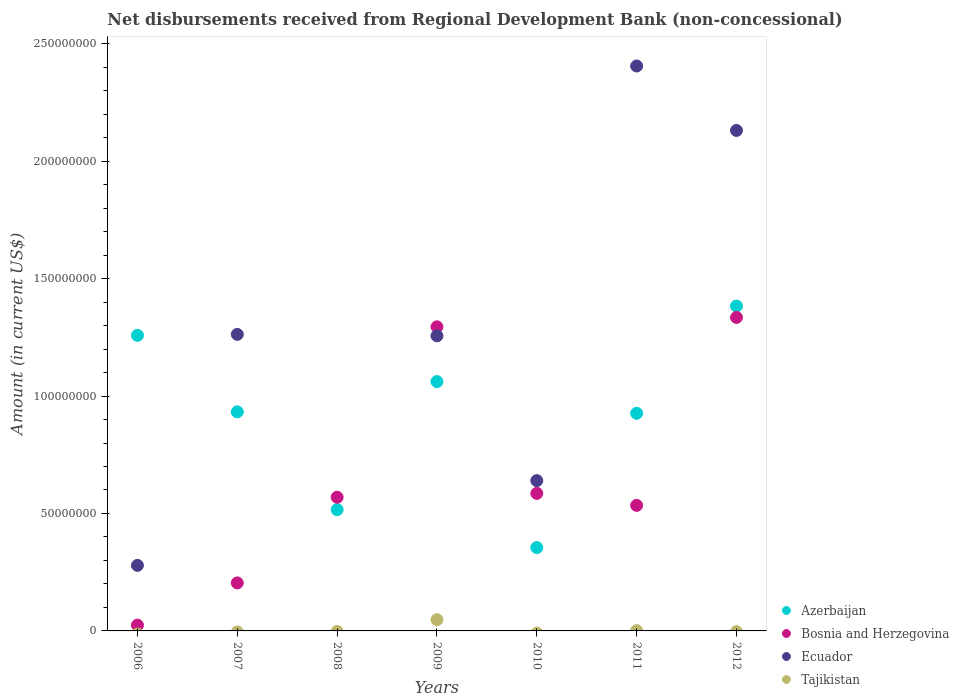How many different coloured dotlines are there?
Give a very brief answer. 4. What is the amount of disbursements received from Regional Development Bank in Ecuador in 2010?
Make the answer very short. 6.40e+07. Across all years, what is the maximum amount of disbursements received from Regional Development Bank in Ecuador?
Ensure brevity in your answer.  2.41e+08. Across all years, what is the minimum amount of disbursements received from Regional Development Bank in Bosnia and Herzegovina?
Your answer should be very brief. 2.46e+06. In which year was the amount of disbursements received from Regional Development Bank in Bosnia and Herzegovina maximum?
Provide a short and direct response. 2012. What is the total amount of disbursements received from Regional Development Bank in Tajikistan in the graph?
Keep it short and to the point. 4.91e+06. What is the difference between the amount of disbursements received from Regional Development Bank in Azerbaijan in 2007 and that in 2012?
Give a very brief answer. -4.50e+07. What is the difference between the amount of disbursements received from Regional Development Bank in Azerbaijan in 2006 and the amount of disbursements received from Regional Development Bank in Ecuador in 2009?
Give a very brief answer. 2.19e+05. What is the average amount of disbursements received from Regional Development Bank in Ecuador per year?
Offer a terse response. 1.14e+08. In the year 2009, what is the difference between the amount of disbursements received from Regional Development Bank in Tajikistan and amount of disbursements received from Regional Development Bank in Ecuador?
Provide a short and direct response. -1.21e+08. What is the ratio of the amount of disbursements received from Regional Development Bank in Ecuador in 2007 to that in 2011?
Provide a short and direct response. 0.52. Is the amount of disbursements received from Regional Development Bank in Azerbaijan in 2006 less than that in 2009?
Your response must be concise. No. What is the difference between the highest and the second highest amount of disbursements received from Regional Development Bank in Ecuador?
Ensure brevity in your answer.  2.74e+07. What is the difference between the highest and the lowest amount of disbursements received from Regional Development Bank in Ecuador?
Your answer should be compact. 2.41e+08. Is the sum of the amount of disbursements received from Regional Development Bank in Azerbaijan in 2006 and 2010 greater than the maximum amount of disbursements received from Regional Development Bank in Ecuador across all years?
Provide a short and direct response. No. Is it the case that in every year, the sum of the amount of disbursements received from Regional Development Bank in Tajikistan and amount of disbursements received from Regional Development Bank in Bosnia and Herzegovina  is greater than the sum of amount of disbursements received from Regional Development Bank in Azerbaijan and amount of disbursements received from Regional Development Bank in Ecuador?
Your answer should be compact. No. Is it the case that in every year, the sum of the amount of disbursements received from Regional Development Bank in Azerbaijan and amount of disbursements received from Regional Development Bank in Tajikistan  is greater than the amount of disbursements received from Regional Development Bank in Bosnia and Herzegovina?
Make the answer very short. No. Is the amount of disbursements received from Regional Development Bank in Tajikistan strictly greater than the amount of disbursements received from Regional Development Bank in Ecuador over the years?
Ensure brevity in your answer.  No. Is the amount of disbursements received from Regional Development Bank in Tajikistan strictly less than the amount of disbursements received from Regional Development Bank in Bosnia and Herzegovina over the years?
Keep it short and to the point. Yes. Does the graph contain grids?
Offer a very short reply. No. Where does the legend appear in the graph?
Provide a short and direct response. Bottom right. How many legend labels are there?
Offer a terse response. 4. What is the title of the graph?
Offer a very short reply. Net disbursements received from Regional Development Bank (non-concessional). Does "Iraq" appear as one of the legend labels in the graph?
Ensure brevity in your answer.  No. What is the label or title of the X-axis?
Give a very brief answer. Years. What is the Amount (in current US$) in Azerbaijan in 2006?
Offer a terse response. 1.26e+08. What is the Amount (in current US$) of Bosnia and Herzegovina in 2006?
Your answer should be very brief. 2.46e+06. What is the Amount (in current US$) of Ecuador in 2006?
Offer a very short reply. 2.79e+07. What is the Amount (in current US$) in Azerbaijan in 2007?
Ensure brevity in your answer.  9.33e+07. What is the Amount (in current US$) in Bosnia and Herzegovina in 2007?
Ensure brevity in your answer.  2.04e+07. What is the Amount (in current US$) of Ecuador in 2007?
Ensure brevity in your answer.  1.26e+08. What is the Amount (in current US$) of Azerbaijan in 2008?
Keep it short and to the point. 5.16e+07. What is the Amount (in current US$) in Bosnia and Herzegovina in 2008?
Your answer should be very brief. 5.69e+07. What is the Amount (in current US$) in Tajikistan in 2008?
Your answer should be very brief. 0. What is the Amount (in current US$) in Azerbaijan in 2009?
Offer a terse response. 1.06e+08. What is the Amount (in current US$) of Bosnia and Herzegovina in 2009?
Your response must be concise. 1.29e+08. What is the Amount (in current US$) of Ecuador in 2009?
Ensure brevity in your answer.  1.26e+08. What is the Amount (in current US$) of Tajikistan in 2009?
Your answer should be very brief. 4.79e+06. What is the Amount (in current US$) of Azerbaijan in 2010?
Make the answer very short. 3.55e+07. What is the Amount (in current US$) in Bosnia and Herzegovina in 2010?
Offer a very short reply. 5.86e+07. What is the Amount (in current US$) in Ecuador in 2010?
Offer a very short reply. 6.40e+07. What is the Amount (in current US$) of Tajikistan in 2010?
Your answer should be compact. 0. What is the Amount (in current US$) in Azerbaijan in 2011?
Make the answer very short. 9.27e+07. What is the Amount (in current US$) in Bosnia and Herzegovina in 2011?
Give a very brief answer. 5.34e+07. What is the Amount (in current US$) in Ecuador in 2011?
Your answer should be compact. 2.41e+08. What is the Amount (in current US$) of Tajikistan in 2011?
Make the answer very short. 1.25e+05. What is the Amount (in current US$) in Azerbaijan in 2012?
Offer a terse response. 1.38e+08. What is the Amount (in current US$) of Bosnia and Herzegovina in 2012?
Ensure brevity in your answer.  1.33e+08. What is the Amount (in current US$) of Ecuador in 2012?
Provide a succinct answer. 2.13e+08. What is the Amount (in current US$) of Tajikistan in 2012?
Provide a short and direct response. 0. Across all years, what is the maximum Amount (in current US$) of Azerbaijan?
Keep it short and to the point. 1.38e+08. Across all years, what is the maximum Amount (in current US$) of Bosnia and Herzegovina?
Keep it short and to the point. 1.33e+08. Across all years, what is the maximum Amount (in current US$) of Ecuador?
Offer a very short reply. 2.41e+08. Across all years, what is the maximum Amount (in current US$) in Tajikistan?
Ensure brevity in your answer.  4.79e+06. Across all years, what is the minimum Amount (in current US$) in Azerbaijan?
Give a very brief answer. 3.55e+07. Across all years, what is the minimum Amount (in current US$) in Bosnia and Herzegovina?
Offer a terse response. 2.46e+06. What is the total Amount (in current US$) in Azerbaijan in the graph?
Keep it short and to the point. 6.43e+08. What is the total Amount (in current US$) in Bosnia and Herzegovina in the graph?
Your response must be concise. 4.55e+08. What is the total Amount (in current US$) of Ecuador in the graph?
Keep it short and to the point. 7.97e+08. What is the total Amount (in current US$) of Tajikistan in the graph?
Give a very brief answer. 4.91e+06. What is the difference between the Amount (in current US$) of Azerbaijan in 2006 and that in 2007?
Your answer should be compact. 3.26e+07. What is the difference between the Amount (in current US$) in Bosnia and Herzegovina in 2006 and that in 2007?
Provide a short and direct response. -1.80e+07. What is the difference between the Amount (in current US$) in Ecuador in 2006 and that in 2007?
Offer a terse response. -9.83e+07. What is the difference between the Amount (in current US$) of Azerbaijan in 2006 and that in 2008?
Offer a very short reply. 7.42e+07. What is the difference between the Amount (in current US$) of Bosnia and Herzegovina in 2006 and that in 2008?
Your answer should be compact. -5.45e+07. What is the difference between the Amount (in current US$) in Azerbaijan in 2006 and that in 2009?
Provide a succinct answer. 1.97e+07. What is the difference between the Amount (in current US$) in Bosnia and Herzegovina in 2006 and that in 2009?
Offer a very short reply. -1.27e+08. What is the difference between the Amount (in current US$) in Ecuador in 2006 and that in 2009?
Your answer should be very brief. -9.77e+07. What is the difference between the Amount (in current US$) in Azerbaijan in 2006 and that in 2010?
Your answer should be compact. 9.04e+07. What is the difference between the Amount (in current US$) of Bosnia and Herzegovina in 2006 and that in 2010?
Provide a short and direct response. -5.61e+07. What is the difference between the Amount (in current US$) in Ecuador in 2006 and that in 2010?
Your answer should be very brief. -3.61e+07. What is the difference between the Amount (in current US$) of Azerbaijan in 2006 and that in 2011?
Provide a short and direct response. 3.32e+07. What is the difference between the Amount (in current US$) of Bosnia and Herzegovina in 2006 and that in 2011?
Offer a very short reply. -5.10e+07. What is the difference between the Amount (in current US$) in Ecuador in 2006 and that in 2011?
Make the answer very short. -2.13e+08. What is the difference between the Amount (in current US$) of Azerbaijan in 2006 and that in 2012?
Your answer should be very brief. -1.25e+07. What is the difference between the Amount (in current US$) in Bosnia and Herzegovina in 2006 and that in 2012?
Your answer should be compact. -1.31e+08. What is the difference between the Amount (in current US$) of Ecuador in 2006 and that in 2012?
Give a very brief answer. -1.85e+08. What is the difference between the Amount (in current US$) of Azerbaijan in 2007 and that in 2008?
Your answer should be very brief. 4.16e+07. What is the difference between the Amount (in current US$) of Bosnia and Herzegovina in 2007 and that in 2008?
Your response must be concise. -3.65e+07. What is the difference between the Amount (in current US$) of Azerbaijan in 2007 and that in 2009?
Your answer should be very brief. -1.29e+07. What is the difference between the Amount (in current US$) of Bosnia and Herzegovina in 2007 and that in 2009?
Provide a short and direct response. -1.09e+08. What is the difference between the Amount (in current US$) of Ecuador in 2007 and that in 2009?
Provide a short and direct response. 6.24e+05. What is the difference between the Amount (in current US$) in Azerbaijan in 2007 and that in 2010?
Offer a terse response. 5.78e+07. What is the difference between the Amount (in current US$) in Bosnia and Herzegovina in 2007 and that in 2010?
Offer a very short reply. -3.81e+07. What is the difference between the Amount (in current US$) of Ecuador in 2007 and that in 2010?
Offer a terse response. 6.23e+07. What is the difference between the Amount (in current US$) of Azerbaijan in 2007 and that in 2011?
Provide a short and direct response. 6.07e+05. What is the difference between the Amount (in current US$) in Bosnia and Herzegovina in 2007 and that in 2011?
Provide a short and direct response. -3.30e+07. What is the difference between the Amount (in current US$) in Ecuador in 2007 and that in 2011?
Your answer should be compact. -1.14e+08. What is the difference between the Amount (in current US$) of Azerbaijan in 2007 and that in 2012?
Provide a succinct answer. -4.50e+07. What is the difference between the Amount (in current US$) in Bosnia and Herzegovina in 2007 and that in 2012?
Give a very brief answer. -1.13e+08. What is the difference between the Amount (in current US$) of Ecuador in 2007 and that in 2012?
Keep it short and to the point. -8.68e+07. What is the difference between the Amount (in current US$) in Azerbaijan in 2008 and that in 2009?
Offer a terse response. -5.45e+07. What is the difference between the Amount (in current US$) of Bosnia and Herzegovina in 2008 and that in 2009?
Offer a very short reply. -7.26e+07. What is the difference between the Amount (in current US$) of Azerbaijan in 2008 and that in 2010?
Make the answer very short. 1.62e+07. What is the difference between the Amount (in current US$) in Bosnia and Herzegovina in 2008 and that in 2010?
Your answer should be very brief. -1.64e+06. What is the difference between the Amount (in current US$) in Azerbaijan in 2008 and that in 2011?
Ensure brevity in your answer.  -4.10e+07. What is the difference between the Amount (in current US$) in Bosnia and Herzegovina in 2008 and that in 2011?
Offer a very short reply. 3.47e+06. What is the difference between the Amount (in current US$) in Azerbaijan in 2008 and that in 2012?
Your response must be concise. -8.67e+07. What is the difference between the Amount (in current US$) in Bosnia and Herzegovina in 2008 and that in 2012?
Make the answer very short. -7.66e+07. What is the difference between the Amount (in current US$) of Azerbaijan in 2009 and that in 2010?
Make the answer very short. 7.07e+07. What is the difference between the Amount (in current US$) in Bosnia and Herzegovina in 2009 and that in 2010?
Keep it short and to the point. 7.09e+07. What is the difference between the Amount (in current US$) of Ecuador in 2009 and that in 2010?
Ensure brevity in your answer.  6.16e+07. What is the difference between the Amount (in current US$) in Azerbaijan in 2009 and that in 2011?
Provide a short and direct response. 1.35e+07. What is the difference between the Amount (in current US$) of Bosnia and Herzegovina in 2009 and that in 2011?
Provide a succinct answer. 7.60e+07. What is the difference between the Amount (in current US$) of Ecuador in 2009 and that in 2011?
Make the answer very short. -1.15e+08. What is the difference between the Amount (in current US$) of Tajikistan in 2009 and that in 2011?
Provide a succinct answer. 4.66e+06. What is the difference between the Amount (in current US$) in Azerbaijan in 2009 and that in 2012?
Give a very brief answer. -3.22e+07. What is the difference between the Amount (in current US$) in Bosnia and Herzegovina in 2009 and that in 2012?
Offer a terse response. -4.00e+06. What is the difference between the Amount (in current US$) in Ecuador in 2009 and that in 2012?
Give a very brief answer. -8.74e+07. What is the difference between the Amount (in current US$) in Azerbaijan in 2010 and that in 2011?
Your answer should be very brief. -5.72e+07. What is the difference between the Amount (in current US$) in Bosnia and Herzegovina in 2010 and that in 2011?
Offer a terse response. 5.11e+06. What is the difference between the Amount (in current US$) of Ecuador in 2010 and that in 2011?
Give a very brief answer. -1.77e+08. What is the difference between the Amount (in current US$) in Azerbaijan in 2010 and that in 2012?
Make the answer very short. -1.03e+08. What is the difference between the Amount (in current US$) of Bosnia and Herzegovina in 2010 and that in 2012?
Offer a terse response. -7.49e+07. What is the difference between the Amount (in current US$) of Ecuador in 2010 and that in 2012?
Ensure brevity in your answer.  -1.49e+08. What is the difference between the Amount (in current US$) of Azerbaijan in 2011 and that in 2012?
Your answer should be compact. -4.56e+07. What is the difference between the Amount (in current US$) in Bosnia and Herzegovina in 2011 and that in 2012?
Provide a short and direct response. -8.00e+07. What is the difference between the Amount (in current US$) in Ecuador in 2011 and that in 2012?
Offer a very short reply. 2.74e+07. What is the difference between the Amount (in current US$) in Azerbaijan in 2006 and the Amount (in current US$) in Bosnia and Herzegovina in 2007?
Offer a terse response. 1.05e+08. What is the difference between the Amount (in current US$) of Azerbaijan in 2006 and the Amount (in current US$) of Ecuador in 2007?
Give a very brief answer. -4.05e+05. What is the difference between the Amount (in current US$) in Bosnia and Herzegovina in 2006 and the Amount (in current US$) in Ecuador in 2007?
Provide a succinct answer. -1.24e+08. What is the difference between the Amount (in current US$) of Azerbaijan in 2006 and the Amount (in current US$) of Bosnia and Herzegovina in 2008?
Make the answer very short. 6.89e+07. What is the difference between the Amount (in current US$) in Azerbaijan in 2006 and the Amount (in current US$) in Bosnia and Herzegovina in 2009?
Your response must be concise. -3.62e+06. What is the difference between the Amount (in current US$) in Azerbaijan in 2006 and the Amount (in current US$) in Ecuador in 2009?
Offer a very short reply. 2.19e+05. What is the difference between the Amount (in current US$) of Azerbaijan in 2006 and the Amount (in current US$) of Tajikistan in 2009?
Make the answer very short. 1.21e+08. What is the difference between the Amount (in current US$) in Bosnia and Herzegovina in 2006 and the Amount (in current US$) in Ecuador in 2009?
Provide a succinct answer. -1.23e+08. What is the difference between the Amount (in current US$) in Bosnia and Herzegovina in 2006 and the Amount (in current US$) in Tajikistan in 2009?
Keep it short and to the point. -2.33e+06. What is the difference between the Amount (in current US$) in Ecuador in 2006 and the Amount (in current US$) in Tajikistan in 2009?
Your answer should be compact. 2.31e+07. What is the difference between the Amount (in current US$) of Azerbaijan in 2006 and the Amount (in current US$) of Bosnia and Herzegovina in 2010?
Make the answer very short. 6.73e+07. What is the difference between the Amount (in current US$) in Azerbaijan in 2006 and the Amount (in current US$) in Ecuador in 2010?
Provide a succinct answer. 6.19e+07. What is the difference between the Amount (in current US$) in Bosnia and Herzegovina in 2006 and the Amount (in current US$) in Ecuador in 2010?
Offer a terse response. -6.15e+07. What is the difference between the Amount (in current US$) of Azerbaijan in 2006 and the Amount (in current US$) of Bosnia and Herzegovina in 2011?
Your answer should be very brief. 7.24e+07. What is the difference between the Amount (in current US$) in Azerbaijan in 2006 and the Amount (in current US$) in Ecuador in 2011?
Your response must be concise. -1.15e+08. What is the difference between the Amount (in current US$) of Azerbaijan in 2006 and the Amount (in current US$) of Tajikistan in 2011?
Make the answer very short. 1.26e+08. What is the difference between the Amount (in current US$) of Bosnia and Herzegovina in 2006 and the Amount (in current US$) of Ecuador in 2011?
Provide a succinct answer. -2.38e+08. What is the difference between the Amount (in current US$) in Bosnia and Herzegovina in 2006 and the Amount (in current US$) in Tajikistan in 2011?
Provide a short and direct response. 2.33e+06. What is the difference between the Amount (in current US$) of Ecuador in 2006 and the Amount (in current US$) of Tajikistan in 2011?
Offer a very short reply. 2.78e+07. What is the difference between the Amount (in current US$) of Azerbaijan in 2006 and the Amount (in current US$) of Bosnia and Herzegovina in 2012?
Offer a very short reply. -7.61e+06. What is the difference between the Amount (in current US$) of Azerbaijan in 2006 and the Amount (in current US$) of Ecuador in 2012?
Provide a succinct answer. -8.72e+07. What is the difference between the Amount (in current US$) of Bosnia and Herzegovina in 2006 and the Amount (in current US$) of Ecuador in 2012?
Provide a succinct answer. -2.11e+08. What is the difference between the Amount (in current US$) of Azerbaijan in 2007 and the Amount (in current US$) of Bosnia and Herzegovina in 2008?
Your response must be concise. 3.64e+07. What is the difference between the Amount (in current US$) in Azerbaijan in 2007 and the Amount (in current US$) in Bosnia and Herzegovina in 2009?
Make the answer very short. -3.62e+07. What is the difference between the Amount (in current US$) of Azerbaijan in 2007 and the Amount (in current US$) of Ecuador in 2009?
Provide a short and direct response. -3.24e+07. What is the difference between the Amount (in current US$) in Azerbaijan in 2007 and the Amount (in current US$) in Tajikistan in 2009?
Provide a succinct answer. 8.85e+07. What is the difference between the Amount (in current US$) in Bosnia and Herzegovina in 2007 and the Amount (in current US$) in Ecuador in 2009?
Offer a very short reply. -1.05e+08. What is the difference between the Amount (in current US$) in Bosnia and Herzegovina in 2007 and the Amount (in current US$) in Tajikistan in 2009?
Make the answer very short. 1.57e+07. What is the difference between the Amount (in current US$) of Ecuador in 2007 and the Amount (in current US$) of Tajikistan in 2009?
Your response must be concise. 1.21e+08. What is the difference between the Amount (in current US$) in Azerbaijan in 2007 and the Amount (in current US$) in Bosnia and Herzegovina in 2010?
Make the answer very short. 3.47e+07. What is the difference between the Amount (in current US$) of Azerbaijan in 2007 and the Amount (in current US$) of Ecuador in 2010?
Offer a terse response. 2.93e+07. What is the difference between the Amount (in current US$) of Bosnia and Herzegovina in 2007 and the Amount (in current US$) of Ecuador in 2010?
Your answer should be very brief. -4.35e+07. What is the difference between the Amount (in current US$) in Azerbaijan in 2007 and the Amount (in current US$) in Bosnia and Herzegovina in 2011?
Provide a succinct answer. 3.98e+07. What is the difference between the Amount (in current US$) of Azerbaijan in 2007 and the Amount (in current US$) of Ecuador in 2011?
Ensure brevity in your answer.  -1.47e+08. What is the difference between the Amount (in current US$) of Azerbaijan in 2007 and the Amount (in current US$) of Tajikistan in 2011?
Ensure brevity in your answer.  9.31e+07. What is the difference between the Amount (in current US$) of Bosnia and Herzegovina in 2007 and the Amount (in current US$) of Ecuador in 2011?
Your response must be concise. -2.20e+08. What is the difference between the Amount (in current US$) of Bosnia and Herzegovina in 2007 and the Amount (in current US$) of Tajikistan in 2011?
Your answer should be very brief. 2.03e+07. What is the difference between the Amount (in current US$) of Ecuador in 2007 and the Amount (in current US$) of Tajikistan in 2011?
Your response must be concise. 1.26e+08. What is the difference between the Amount (in current US$) of Azerbaijan in 2007 and the Amount (in current US$) of Bosnia and Herzegovina in 2012?
Provide a succinct answer. -4.02e+07. What is the difference between the Amount (in current US$) of Azerbaijan in 2007 and the Amount (in current US$) of Ecuador in 2012?
Provide a short and direct response. -1.20e+08. What is the difference between the Amount (in current US$) in Bosnia and Herzegovina in 2007 and the Amount (in current US$) in Ecuador in 2012?
Provide a succinct answer. -1.93e+08. What is the difference between the Amount (in current US$) of Azerbaijan in 2008 and the Amount (in current US$) of Bosnia and Herzegovina in 2009?
Your response must be concise. -7.78e+07. What is the difference between the Amount (in current US$) in Azerbaijan in 2008 and the Amount (in current US$) in Ecuador in 2009?
Offer a very short reply. -7.40e+07. What is the difference between the Amount (in current US$) of Azerbaijan in 2008 and the Amount (in current US$) of Tajikistan in 2009?
Ensure brevity in your answer.  4.68e+07. What is the difference between the Amount (in current US$) of Bosnia and Herzegovina in 2008 and the Amount (in current US$) of Ecuador in 2009?
Ensure brevity in your answer.  -6.87e+07. What is the difference between the Amount (in current US$) of Bosnia and Herzegovina in 2008 and the Amount (in current US$) of Tajikistan in 2009?
Offer a terse response. 5.21e+07. What is the difference between the Amount (in current US$) of Azerbaijan in 2008 and the Amount (in current US$) of Bosnia and Herzegovina in 2010?
Make the answer very short. -6.92e+06. What is the difference between the Amount (in current US$) in Azerbaijan in 2008 and the Amount (in current US$) in Ecuador in 2010?
Give a very brief answer. -1.24e+07. What is the difference between the Amount (in current US$) of Bosnia and Herzegovina in 2008 and the Amount (in current US$) of Ecuador in 2010?
Make the answer very short. -7.08e+06. What is the difference between the Amount (in current US$) in Azerbaijan in 2008 and the Amount (in current US$) in Bosnia and Herzegovina in 2011?
Your answer should be compact. -1.81e+06. What is the difference between the Amount (in current US$) of Azerbaijan in 2008 and the Amount (in current US$) of Ecuador in 2011?
Ensure brevity in your answer.  -1.89e+08. What is the difference between the Amount (in current US$) of Azerbaijan in 2008 and the Amount (in current US$) of Tajikistan in 2011?
Give a very brief answer. 5.15e+07. What is the difference between the Amount (in current US$) of Bosnia and Herzegovina in 2008 and the Amount (in current US$) of Ecuador in 2011?
Provide a short and direct response. -1.84e+08. What is the difference between the Amount (in current US$) of Bosnia and Herzegovina in 2008 and the Amount (in current US$) of Tajikistan in 2011?
Ensure brevity in your answer.  5.68e+07. What is the difference between the Amount (in current US$) in Azerbaijan in 2008 and the Amount (in current US$) in Bosnia and Herzegovina in 2012?
Offer a terse response. -8.18e+07. What is the difference between the Amount (in current US$) of Azerbaijan in 2008 and the Amount (in current US$) of Ecuador in 2012?
Your answer should be very brief. -1.61e+08. What is the difference between the Amount (in current US$) in Bosnia and Herzegovina in 2008 and the Amount (in current US$) in Ecuador in 2012?
Your answer should be compact. -1.56e+08. What is the difference between the Amount (in current US$) in Azerbaijan in 2009 and the Amount (in current US$) in Bosnia and Herzegovina in 2010?
Ensure brevity in your answer.  4.76e+07. What is the difference between the Amount (in current US$) of Azerbaijan in 2009 and the Amount (in current US$) of Ecuador in 2010?
Offer a terse response. 4.22e+07. What is the difference between the Amount (in current US$) in Bosnia and Herzegovina in 2009 and the Amount (in current US$) in Ecuador in 2010?
Your answer should be very brief. 6.55e+07. What is the difference between the Amount (in current US$) of Azerbaijan in 2009 and the Amount (in current US$) of Bosnia and Herzegovina in 2011?
Offer a terse response. 5.27e+07. What is the difference between the Amount (in current US$) of Azerbaijan in 2009 and the Amount (in current US$) of Ecuador in 2011?
Offer a terse response. -1.34e+08. What is the difference between the Amount (in current US$) of Azerbaijan in 2009 and the Amount (in current US$) of Tajikistan in 2011?
Your response must be concise. 1.06e+08. What is the difference between the Amount (in current US$) of Bosnia and Herzegovina in 2009 and the Amount (in current US$) of Ecuador in 2011?
Keep it short and to the point. -1.11e+08. What is the difference between the Amount (in current US$) in Bosnia and Herzegovina in 2009 and the Amount (in current US$) in Tajikistan in 2011?
Ensure brevity in your answer.  1.29e+08. What is the difference between the Amount (in current US$) in Ecuador in 2009 and the Amount (in current US$) in Tajikistan in 2011?
Provide a short and direct response. 1.26e+08. What is the difference between the Amount (in current US$) in Azerbaijan in 2009 and the Amount (in current US$) in Bosnia and Herzegovina in 2012?
Your response must be concise. -2.73e+07. What is the difference between the Amount (in current US$) in Azerbaijan in 2009 and the Amount (in current US$) in Ecuador in 2012?
Offer a very short reply. -1.07e+08. What is the difference between the Amount (in current US$) in Bosnia and Herzegovina in 2009 and the Amount (in current US$) in Ecuador in 2012?
Provide a succinct answer. -8.36e+07. What is the difference between the Amount (in current US$) in Azerbaijan in 2010 and the Amount (in current US$) in Bosnia and Herzegovina in 2011?
Offer a terse response. -1.80e+07. What is the difference between the Amount (in current US$) in Azerbaijan in 2010 and the Amount (in current US$) in Ecuador in 2011?
Offer a terse response. -2.05e+08. What is the difference between the Amount (in current US$) in Azerbaijan in 2010 and the Amount (in current US$) in Tajikistan in 2011?
Provide a succinct answer. 3.54e+07. What is the difference between the Amount (in current US$) in Bosnia and Herzegovina in 2010 and the Amount (in current US$) in Ecuador in 2011?
Provide a succinct answer. -1.82e+08. What is the difference between the Amount (in current US$) in Bosnia and Herzegovina in 2010 and the Amount (in current US$) in Tajikistan in 2011?
Provide a short and direct response. 5.84e+07. What is the difference between the Amount (in current US$) of Ecuador in 2010 and the Amount (in current US$) of Tajikistan in 2011?
Make the answer very short. 6.39e+07. What is the difference between the Amount (in current US$) of Azerbaijan in 2010 and the Amount (in current US$) of Bosnia and Herzegovina in 2012?
Your response must be concise. -9.80e+07. What is the difference between the Amount (in current US$) in Azerbaijan in 2010 and the Amount (in current US$) in Ecuador in 2012?
Your answer should be very brief. -1.78e+08. What is the difference between the Amount (in current US$) in Bosnia and Herzegovina in 2010 and the Amount (in current US$) in Ecuador in 2012?
Offer a very short reply. -1.55e+08. What is the difference between the Amount (in current US$) of Azerbaijan in 2011 and the Amount (in current US$) of Bosnia and Herzegovina in 2012?
Your answer should be very brief. -4.08e+07. What is the difference between the Amount (in current US$) of Azerbaijan in 2011 and the Amount (in current US$) of Ecuador in 2012?
Offer a very short reply. -1.20e+08. What is the difference between the Amount (in current US$) of Bosnia and Herzegovina in 2011 and the Amount (in current US$) of Ecuador in 2012?
Offer a terse response. -1.60e+08. What is the average Amount (in current US$) in Azerbaijan per year?
Your answer should be compact. 9.19e+07. What is the average Amount (in current US$) of Bosnia and Herzegovina per year?
Provide a succinct answer. 6.50e+07. What is the average Amount (in current US$) of Ecuador per year?
Give a very brief answer. 1.14e+08. What is the average Amount (in current US$) of Tajikistan per year?
Offer a terse response. 7.02e+05. In the year 2006, what is the difference between the Amount (in current US$) in Azerbaijan and Amount (in current US$) in Bosnia and Herzegovina?
Ensure brevity in your answer.  1.23e+08. In the year 2006, what is the difference between the Amount (in current US$) of Azerbaijan and Amount (in current US$) of Ecuador?
Keep it short and to the point. 9.79e+07. In the year 2006, what is the difference between the Amount (in current US$) of Bosnia and Herzegovina and Amount (in current US$) of Ecuador?
Offer a terse response. -2.55e+07. In the year 2007, what is the difference between the Amount (in current US$) in Azerbaijan and Amount (in current US$) in Bosnia and Herzegovina?
Your response must be concise. 7.28e+07. In the year 2007, what is the difference between the Amount (in current US$) of Azerbaijan and Amount (in current US$) of Ecuador?
Provide a succinct answer. -3.30e+07. In the year 2007, what is the difference between the Amount (in current US$) of Bosnia and Herzegovina and Amount (in current US$) of Ecuador?
Offer a very short reply. -1.06e+08. In the year 2008, what is the difference between the Amount (in current US$) of Azerbaijan and Amount (in current US$) of Bosnia and Herzegovina?
Your answer should be very brief. -5.28e+06. In the year 2009, what is the difference between the Amount (in current US$) of Azerbaijan and Amount (in current US$) of Bosnia and Herzegovina?
Your answer should be very brief. -2.33e+07. In the year 2009, what is the difference between the Amount (in current US$) in Azerbaijan and Amount (in current US$) in Ecuador?
Offer a very short reply. -1.95e+07. In the year 2009, what is the difference between the Amount (in current US$) in Azerbaijan and Amount (in current US$) in Tajikistan?
Provide a succinct answer. 1.01e+08. In the year 2009, what is the difference between the Amount (in current US$) of Bosnia and Herzegovina and Amount (in current US$) of Ecuador?
Keep it short and to the point. 3.84e+06. In the year 2009, what is the difference between the Amount (in current US$) of Bosnia and Herzegovina and Amount (in current US$) of Tajikistan?
Your answer should be very brief. 1.25e+08. In the year 2009, what is the difference between the Amount (in current US$) in Ecuador and Amount (in current US$) in Tajikistan?
Your answer should be compact. 1.21e+08. In the year 2010, what is the difference between the Amount (in current US$) of Azerbaijan and Amount (in current US$) of Bosnia and Herzegovina?
Ensure brevity in your answer.  -2.31e+07. In the year 2010, what is the difference between the Amount (in current US$) of Azerbaijan and Amount (in current US$) of Ecuador?
Offer a very short reply. -2.85e+07. In the year 2010, what is the difference between the Amount (in current US$) of Bosnia and Herzegovina and Amount (in current US$) of Ecuador?
Offer a terse response. -5.43e+06. In the year 2011, what is the difference between the Amount (in current US$) in Azerbaijan and Amount (in current US$) in Bosnia and Herzegovina?
Provide a short and direct response. 3.92e+07. In the year 2011, what is the difference between the Amount (in current US$) in Azerbaijan and Amount (in current US$) in Ecuador?
Your answer should be very brief. -1.48e+08. In the year 2011, what is the difference between the Amount (in current US$) of Azerbaijan and Amount (in current US$) of Tajikistan?
Give a very brief answer. 9.25e+07. In the year 2011, what is the difference between the Amount (in current US$) of Bosnia and Herzegovina and Amount (in current US$) of Ecuador?
Provide a short and direct response. -1.87e+08. In the year 2011, what is the difference between the Amount (in current US$) in Bosnia and Herzegovina and Amount (in current US$) in Tajikistan?
Your response must be concise. 5.33e+07. In the year 2011, what is the difference between the Amount (in current US$) of Ecuador and Amount (in current US$) of Tajikistan?
Offer a terse response. 2.40e+08. In the year 2012, what is the difference between the Amount (in current US$) of Azerbaijan and Amount (in current US$) of Bosnia and Herzegovina?
Your response must be concise. 4.84e+06. In the year 2012, what is the difference between the Amount (in current US$) of Azerbaijan and Amount (in current US$) of Ecuador?
Keep it short and to the point. -7.48e+07. In the year 2012, what is the difference between the Amount (in current US$) of Bosnia and Herzegovina and Amount (in current US$) of Ecuador?
Your answer should be very brief. -7.96e+07. What is the ratio of the Amount (in current US$) in Azerbaijan in 2006 to that in 2007?
Ensure brevity in your answer.  1.35. What is the ratio of the Amount (in current US$) in Bosnia and Herzegovina in 2006 to that in 2007?
Provide a short and direct response. 0.12. What is the ratio of the Amount (in current US$) of Ecuador in 2006 to that in 2007?
Your answer should be compact. 0.22. What is the ratio of the Amount (in current US$) of Azerbaijan in 2006 to that in 2008?
Your response must be concise. 2.44. What is the ratio of the Amount (in current US$) in Bosnia and Herzegovina in 2006 to that in 2008?
Offer a terse response. 0.04. What is the ratio of the Amount (in current US$) in Azerbaijan in 2006 to that in 2009?
Give a very brief answer. 1.19. What is the ratio of the Amount (in current US$) of Bosnia and Herzegovina in 2006 to that in 2009?
Give a very brief answer. 0.02. What is the ratio of the Amount (in current US$) in Ecuador in 2006 to that in 2009?
Offer a terse response. 0.22. What is the ratio of the Amount (in current US$) of Azerbaijan in 2006 to that in 2010?
Offer a terse response. 3.55. What is the ratio of the Amount (in current US$) of Bosnia and Herzegovina in 2006 to that in 2010?
Make the answer very short. 0.04. What is the ratio of the Amount (in current US$) in Ecuador in 2006 to that in 2010?
Your response must be concise. 0.44. What is the ratio of the Amount (in current US$) in Azerbaijan in 2006 to that in 2011?
Your response must be concise. 1.36. What is the ratio of the Amount (in current US$) in Bosnia and Herzegovina in 2006 to that in 2011?
Keep it short and to the point. 0.05. What is the ratio of the Amount (in current US$) of Ecuador in 2006 to that in 2011?
Ensure brevity in your answer.  0.12. What is the ratio of the Amount (in current US$) in Azerbaijan in 2006 to that in 2012?
Offer a terse response. 0.91. What is the ratio of the Amount (in current US$) of Bosnia and Herzegovina in 2006 to that in 2012?
Offer a terse response. 0.02. What is the ratio of the Amount (in current US$) in Ecuador in 2006 to that in 2012?
Keep it short and to the point. 0.13. What is the ratio of the Amount (in current US$) in Azerbaijan in 2007 to that in 2008?
Your response must be concise. 1.81. What is the ratio of the Amount (in current US$) of Bosnia and Herzegovina in 2007 to that in 2008?
Keep it short and to the point. 0.36. What is the ratio of the Amount (in current US$) of Azerbaijan in 2007 to that in 2009?
Your answer should be very brief. 0.88. What is the ratio of the Amount (in current US$) in Bosnia and Herzegovina in 2007 to that in 2009?
Offer a terse response. 0.16. What is the ratio of the Amount (in current US$) of Ecuador in 2007 to that in 2009?
Your response must be concise. 1. What is the ratio of the Amount (in current US$) of Azerbaijan in 2007 to that in 2010?
Your answer should be very brief. 2.63. What is the ratio of the Amount (in current US$) of Bosnia and Herzegovina in 2007 to that in 2010?
Offer a terse response. 0.35. What is the ratio of the Amount (in current US$) in Ecuador in 2007 to that in 2010?
Ensure brevity in your answer.  1.97. What is the ratio of the Amount (in current US$) of Azerbaijan in 2007 to that in 2011?
Your answer should be very brief. 1.01. What is the ratio of the Amount (in current US$) of Bosnia and Herzegovina in 2007 to that in 2011?
Offer a very short reply. 0.38. What is the ratio of the Amount (in current US$) in Ecuador in 2007 to that in 2011?
Provide a succinct answer. 0.53. What is the ratio of the Amount (in current US$) in Azerbaijan in 2007 to that in 2012?
Provide a succinct answer. 0.67. What is the ratio of the Amount (in current US$) in Bosnia and Herzegovina in 2007 to that in 2012?
Keep it short and to the point. 0.15. What is the ratio of the Amount (in current US$) of Ecuador in 2007 to that in 2012?
Provide a succinct answer. 0.59. What is the ratio of the Amount (in current US$) of Azerbaijan in 2008 to that in 2009?
Ensure brevity in your answer.  0.49. What is the ratio of the Amount (in current US$) in Bosnia and Herzegovina in 2008 to that in 2009?
Your answer should be compact. 0.44. What is the ratio of the Amount (in current US$) in Azerbaijan in 2008 to that in 2010?
Ensure brevity in your answer.  1.46. What is the ratio of the Amount (in current US$) in Bosnia and Herzegovina in 2008 to that in 2010?
Keep it short and to the point. 0.97. What is the ratio of the Amount (in current US$) in Azerbaijan in 2008 to that in 2011?
Offer a terse response. 0.56. What is the ratio of the Amount (in current US$) in Bosnia and Herzegovina in 2008 to that in 2011?
Your answer should be very brief. 1.06. What is the ratio of the Amount (in current US$) in Azerbaijan in 2008 to that in 2012?
Offer a very short reply. 0.37. What is the ratio of the Amount (in current US$) in Bosnia and Herzegovina in 2008 to that in 2012?
Provide a short and direct response. 0.43. What is the ratio of the Amount (in current US$) in Azerbaijan in 2009 to that in 2010?
Offer a very short reply. 2.99. What is the ratio of the Amount (in current US$) in Bosnia and Herzegovina in 2009 to that in 2010?
Your answer should be compact. 2.21. What is the ratio of the Amount (in current US$) in Ecuador in 2009 to that in 2010?
Provide a short and direct response. 1.96. What is the ratio of the Amount (in current US$) of Azerbaijan in 2009 to that in 2011?
Make the answer very short. 1.15. What is the ratio of the Amount (in current US$) of Bosnia and Herzegovina in 2009 to that in 2011?
Ensure brevity in your answer.  2.42. What is the ratio of the Amount (in current US$) in Ecuador in 2009 to that in 2011?
Provide a succinct answer. 0.52. What is the ratio of the Amount (in current US$) in Tajikistan in 2009 to that in 2011?
Provide a succinct answer. 38.31. What is the ratio of the Amount (in current US$) in Azerbaijan in 2009 to that in 2012?
Ensure brevity in your answer.  0.77. What is the ratio of the Amount (in current US$) of Bosnia and Herzegovina in 2009 to that in 2012?
Offer a very short reply. 0.97. What is the ratio of the Amount (in current US$) in Ecuador in 2009 to that in 2012?
Provide a short and direct response. 0.59. What is the ratio of the Amount (in current US$) in Azerbaijan in 2010 to that in 2011?
Make the answer very short. 0.38. What is the ratio of the Amount (in current US$) in Bosnia and Herzegovina in 2010 to that in 2011?
Provide a short and direct response. 1.1. What is the ratio of the Amount (in current US$) in Ecuador in 2010 to that in 2011?
Give a very brief answer. 0.27. What is the ratio of the Amount (in current US$) in Azerbaijan in 2010 to that in 2012?
Offer a terse response. 0.26. What is the ratio of the Amount (in current US$) of Bosnia and Herzegovina in 2010 to that in 2012?
Provide a succinct answer. 0.44. What is the ratio of the Amount (in current US$) of Ecuador in 2010 to that in 2012?
Ensure brevity in your answer.  0.3. What is the ratio of the Amount (in current US$) of Azerbaijan in 2011 to that in 2012?
Keep it short and to the point. 0.67. What is the ratio of the Amount (in current US$) of Bosnia and Herzegovina in 2011 to that in 2012?
Ensure brevity in your answer.  0.4. What is the ratio of the Amount (in current US$) of Ecuador in 2011 to that in 2012?
Ensure brevity in your answer.  1.13. What is the difference between the highest and the second highest Amount (in current US$) in Azerbaijan?
Ensure brevity in your answer.  1.25e+07. What is the difference between the highest and the second highest Amount (in current US$) of Bosnia and Herzegovina?
Provide a short and direct response. 4.00e+06. What is the difference between the highest and the second highest Amount (in current US$) in Ecuador?
Keep it short and to the point. 2.74e+07. What is the difference between the highest and the lowest Amount (in current US$) of Azerbaijan?
Offer a terse response. 1.03e+08. What is the difference between the highest and the lowest Amount (in current US$) in Bosnia and Herzegovina?
Provide a succinct answer. 1.31e+08. What is the difference between the highest and the lowest Amount (in current US$) of Ecuador?
Ensure brevity in your answer.  2.41e+08. What is the difference between the highest and the lowest Amount (in current US$) in Tajikistan?
Provide a short and direct response. 4.79e+06. 